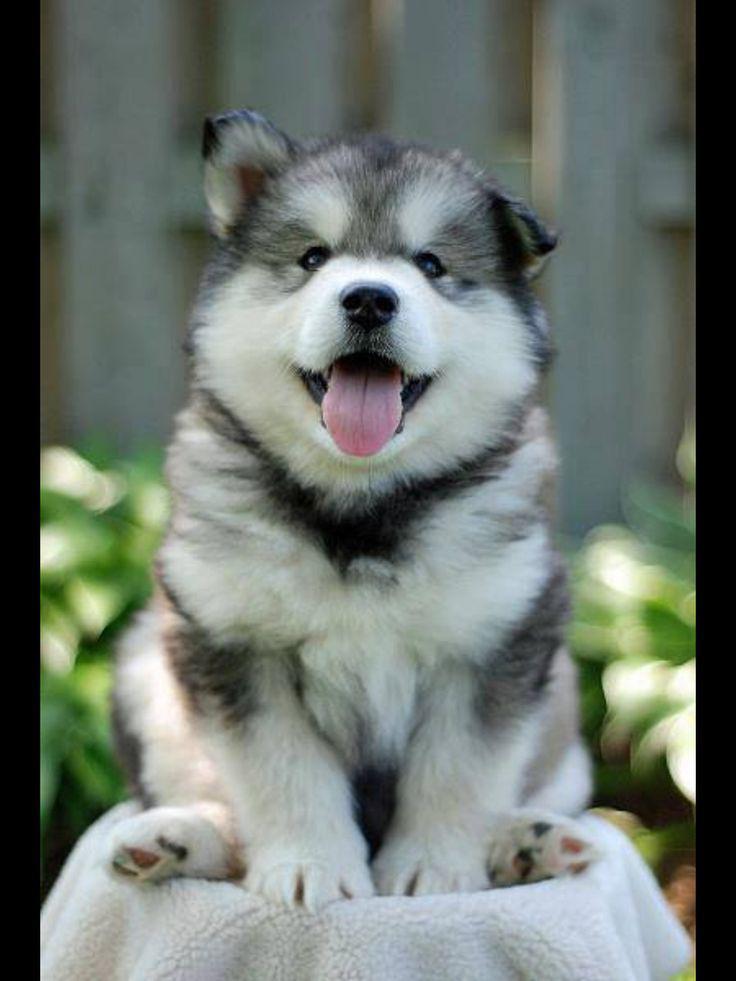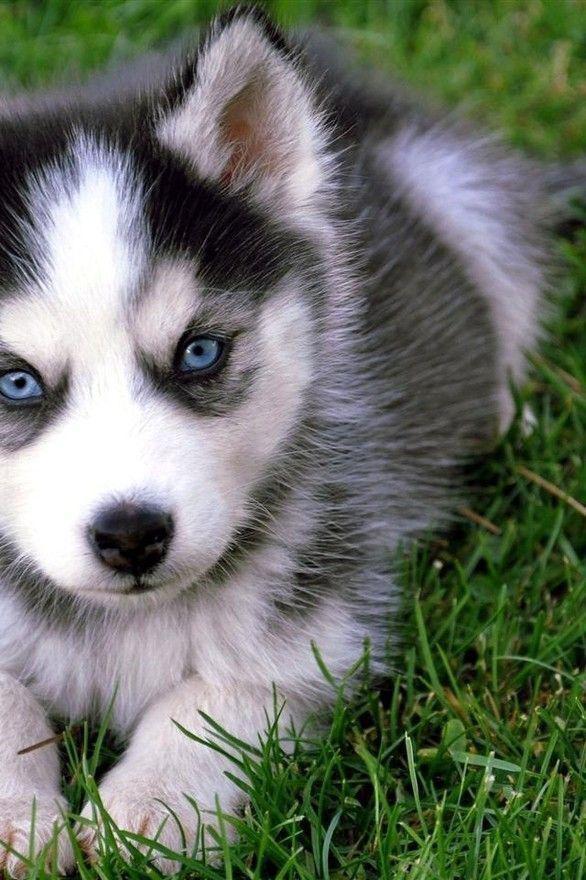The first image is the image on the left, the second image is the image on the right. Examine the images to the left and right. Is the description "The right and left image contains the same number of dogs huskeys." accurate? Answer yes or no. Yes. The first image is the image on the left, the second image is the image on the right. For the images shown, is this caption "The left image includes a blue-eyed husky with bits of icy snow glistening in the fur around its face." true? Answer yes or no. No. 